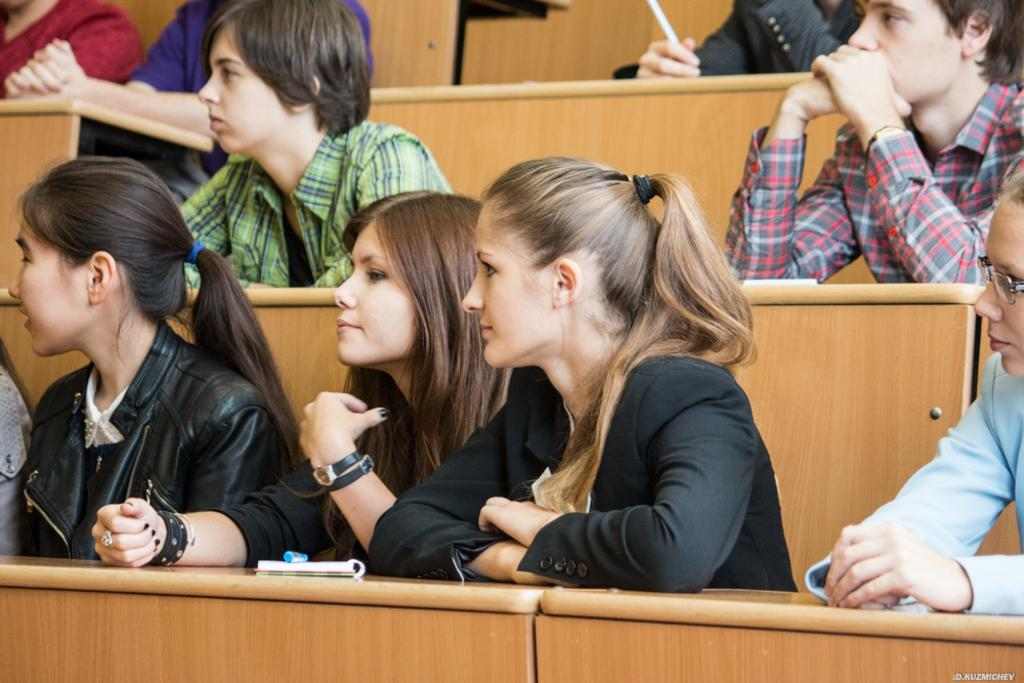What is the main subject of the image? The main subject of the image is a group of people. What are the people doing in the image? The people are sitting on benches. How are the benches arranged in the image? The benches are arranged in a series. Where are the people and benches located in the image? The group of people and benches are in the center of the image. What type of hill can be seen in the background of the image? There is no hill visible in the background of the image. Is there a flag present in the image? No, there is no flag present in the image. 